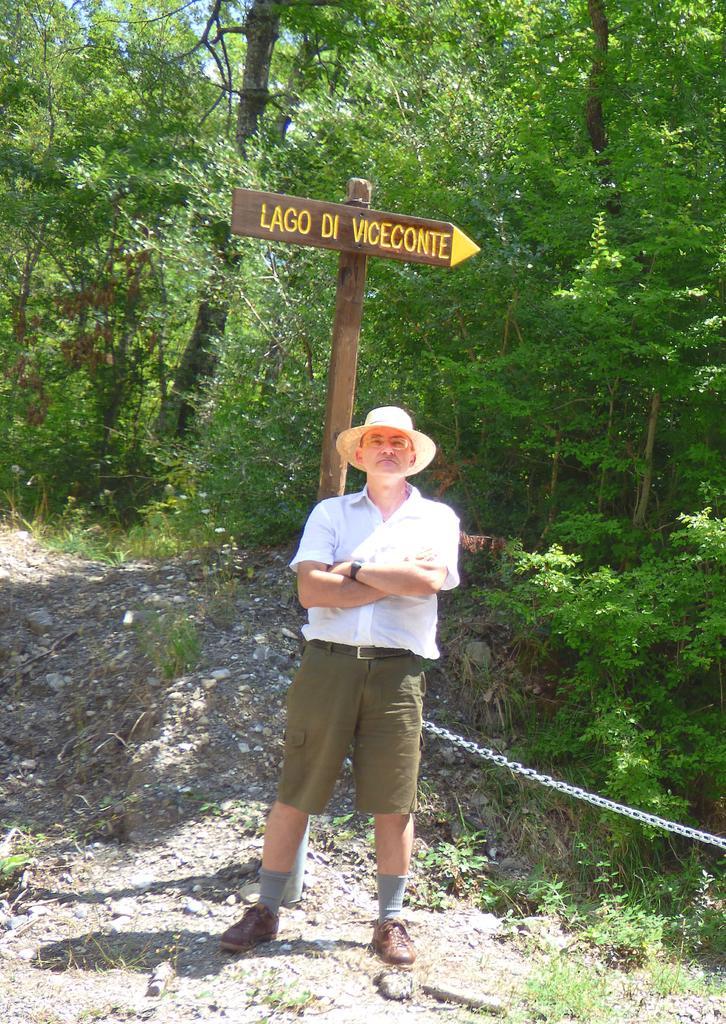Please provide a concise description of this image. In this image, I can see a man standing. In the background, there are trees and I can see a board to a pole. On the right side of the image, I can see an iron chain. 